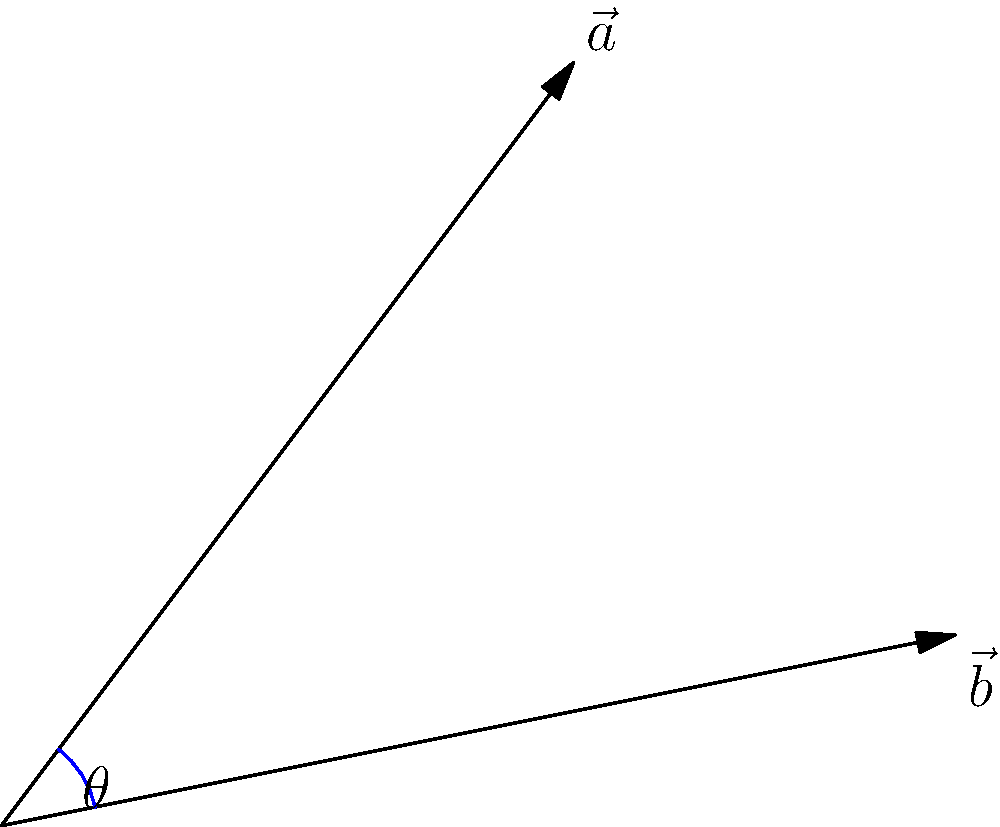In a new mobile game, swipe gestures are represented as vectors. You perform two swipes: $\vec{a} = 3\hat{i} + 4\hat{j}$ and $\vec{b} = 5\hat{i} + \hat{j}$. What is the angle between these two swipe vectors? (Round your answer to the nearest degree, as the game's autocorrect might mess up precise decimals!) To find the angle between two vectors, we can use the dot product formula:

$$\cos \theta = \frac{\vec{a} \cdot \vec{b}}{|\vec{a}||\vec{b}|}$$

Step 1: Calculate the dot product $\vec{a} \cdot \vec{b}$
$$\vec{a} \cdot \vec{b} = (3)(5) + (4)(1) = 15 + 4 = 19$$

Step 2: Calculate the magnitudes of $\vec{a}$ and $\vec{b}$
$$|\vec{a}| = \sqrt{3^2 + 4^2} = \sqrt{9 + 16} = \sqrt{25} = 5$$
$$|\vec{b}| = \sqrt{5^2 + 1^2} = \sqrt{25 + 1} = \sqrt{26}$$

Step 3: Substitute into the formula
$$\cos \theta = \frac{19}{5\sqrt{26}}$$

Step 4: Take the inverse cosine (arccos) of both sides
$$\theta = \arccos(\frac{19}{5\sqrt{26}})$$

Step 5: Calculate and round to the nearest degree
$$\theta \approx 22.6° \approx 23°$$
Answer: 23° 